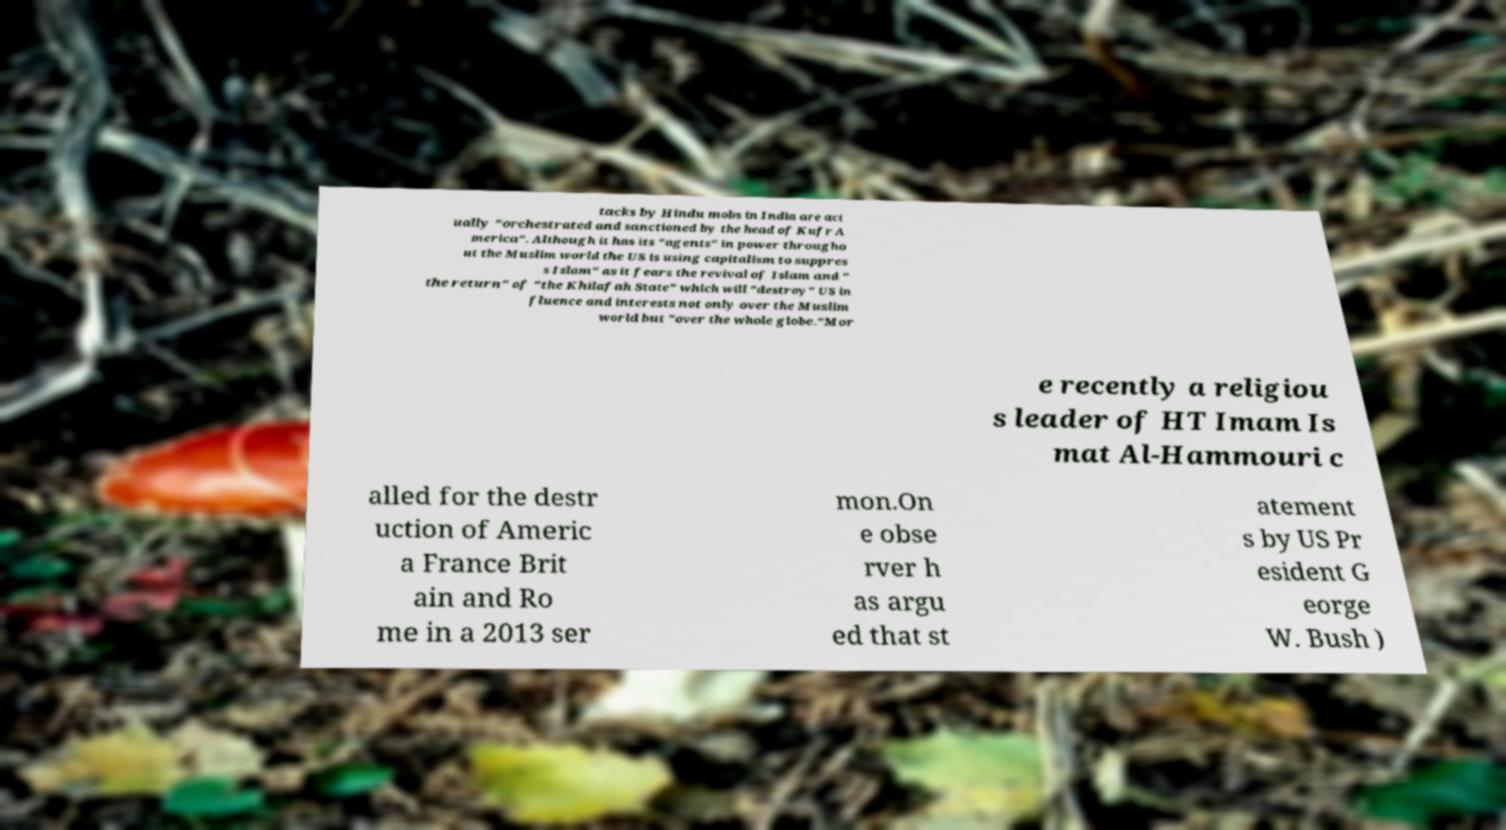I need the written content from this picture converted into text. Can you do that? tacks by Hindu mobs in India are act ually "orchestrated and sanctioned by the head of Kufr A merica". Although it has its "agents" in power througho ut the Muslim world the US is using capitalism to suppres s Islam" as it fears the revival of Islam and " the return" of "the Khilafah State" which will "destroy" US in fluence and interests not only over the Muslim world but "over the whole globe."Mor e recently a religiou s leader of HT Imam Is mat Al-Hammouri c alled for the destr uction of Americ a France Brit ain and Ro me in a 2013 ser mon.On e obse rver h as argu ed that st atement s by US Pr esident G eorge W. Bush ) 